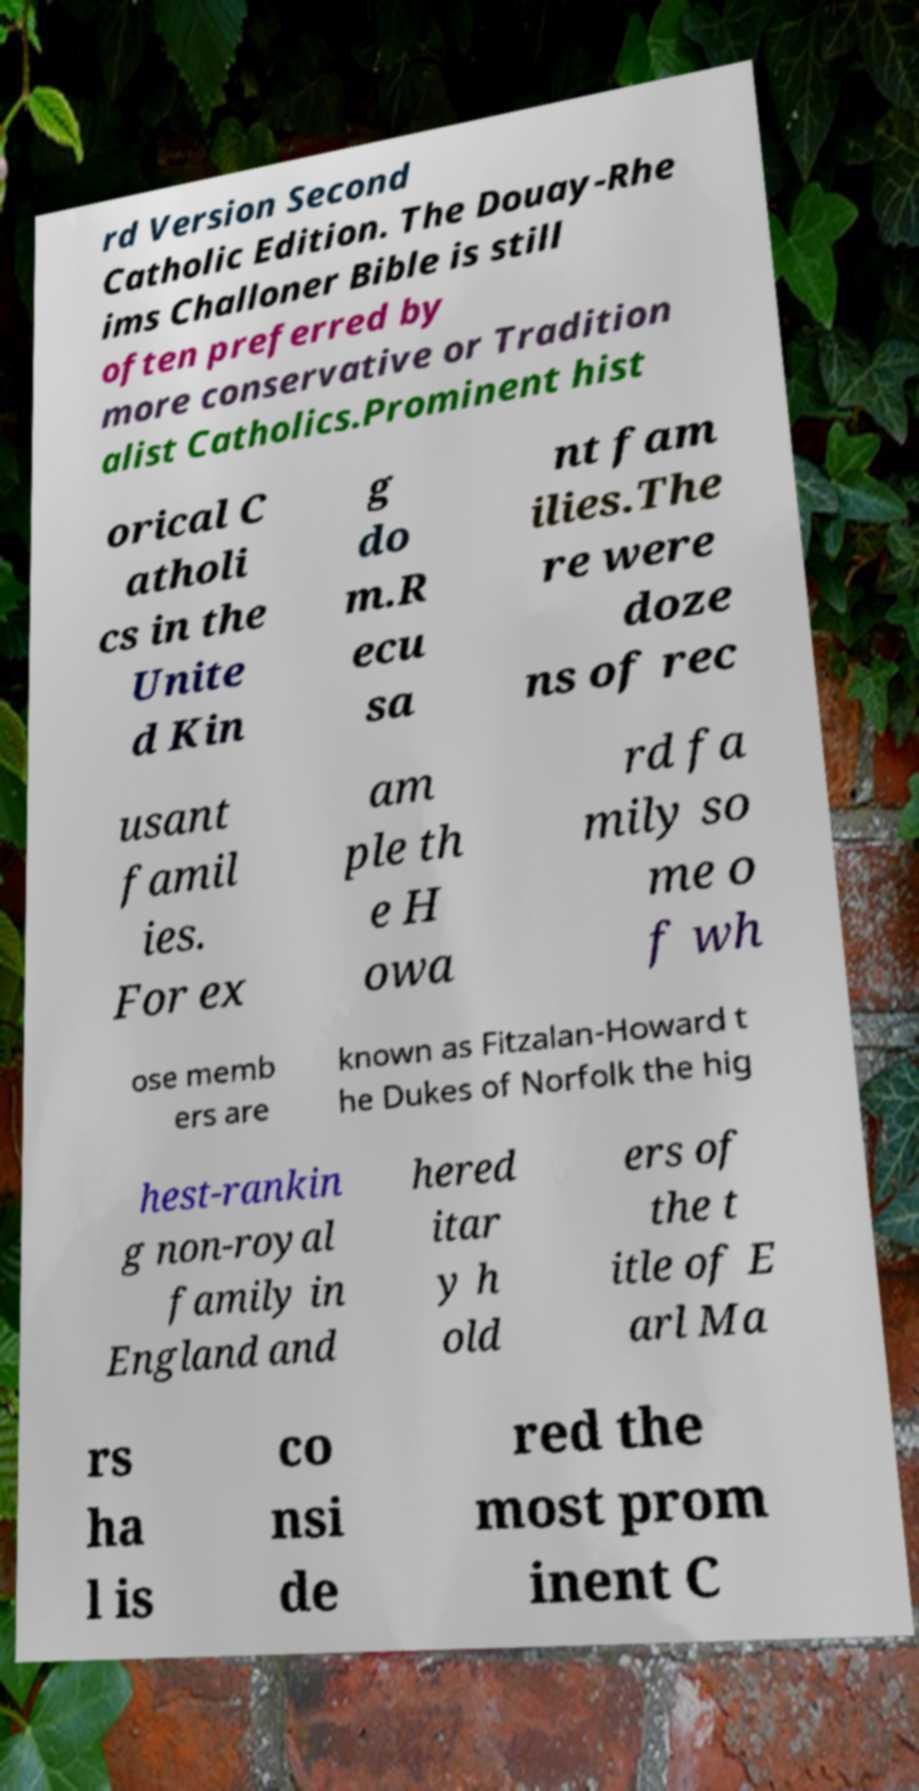Can you read and provide the text displayed in the image?This photo seems to have some interesting text. Can you extract and type it out for me? rd Version Second Catholic Edition. The Douay-Rhe ims Challoner Bible is still often preferred by more conservative or Tradition alist Catholics.Prominent hist orical C atholi cs in the Unite d Kin g do m.R ecu sa nt fam ilies.The re were doze ns of rec usant famil ies. For ex am ple th e H owa rd fa mily so me o f wh ose memb ers are known as Fitzalan-Howard t he Dukes of Norfolk the hig hest-rankin g non-royal family in England and hered itar y h old ers of the t itle of E arl Ma rs ha l is co nsi de red the most prom inent C 